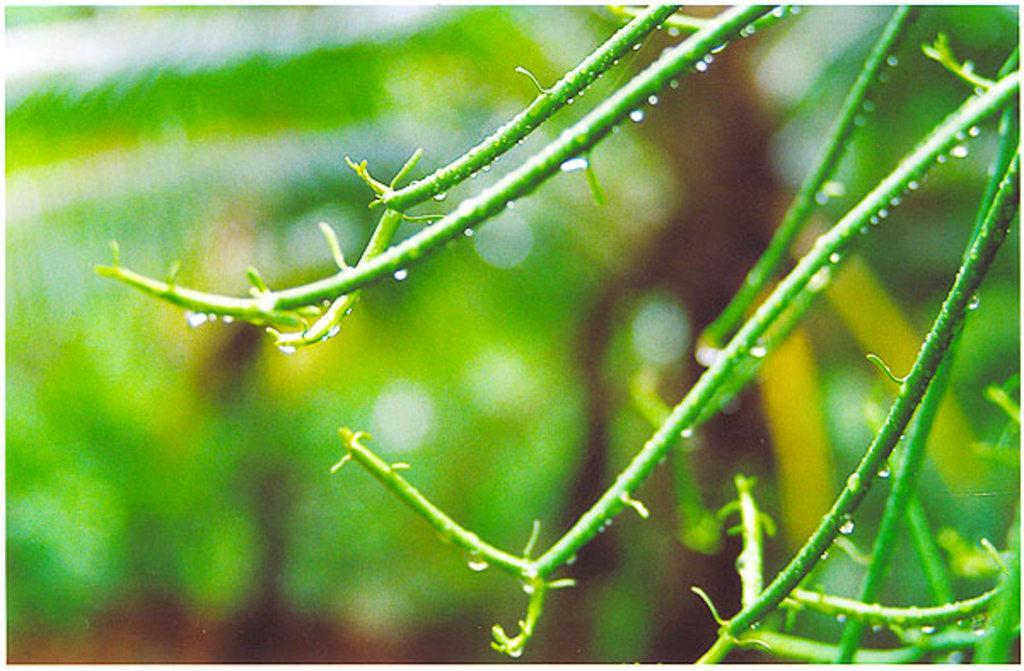Describe this image in one or two sentences. In this image we can see there are few water drops on the stems of a plant. 